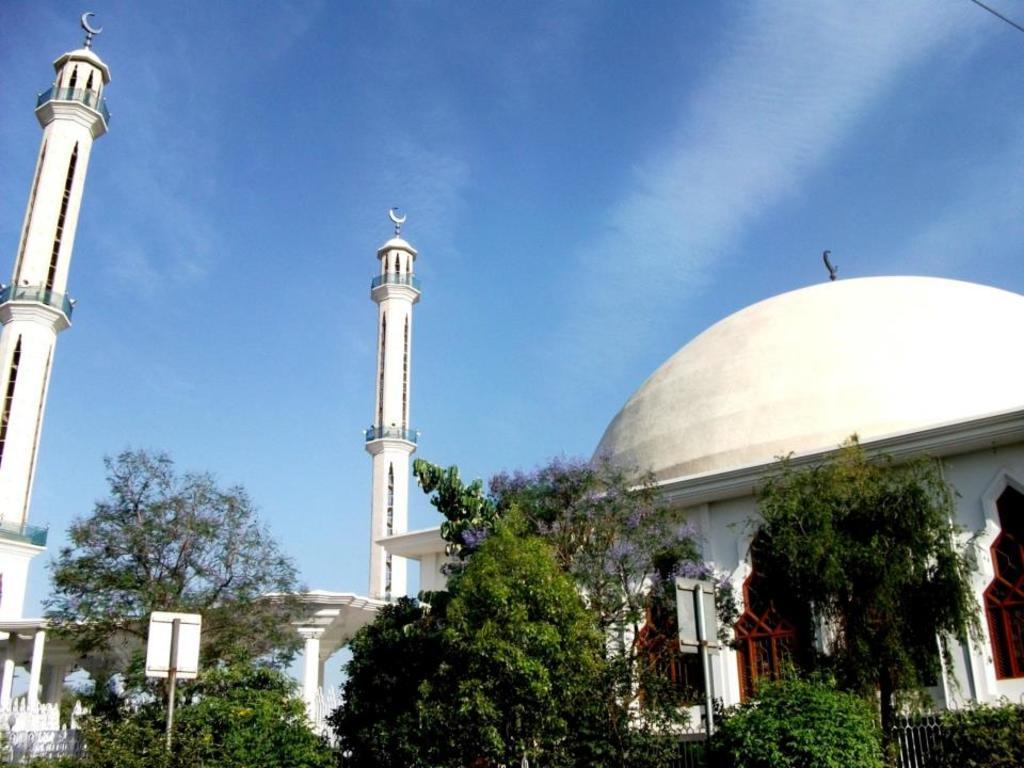In one or two sentences, can you explain what this image depicts? In this image we can see a building with windows and the towers. We can also see a group of trees, a fence, sign boards to a pole and the sky which looks cloudy. 